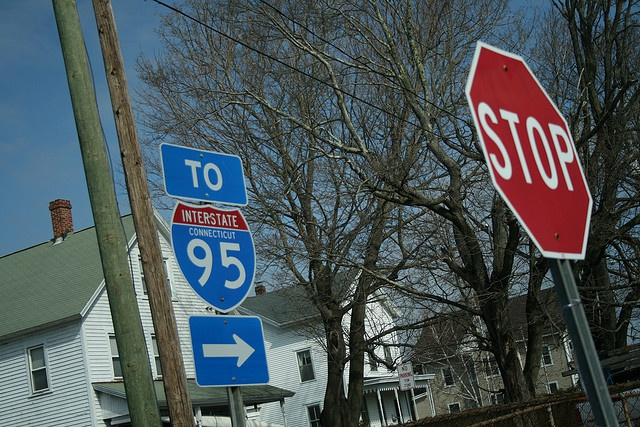Describe the objects in this image and their specific colors. I can see a stop sign in blue, brown, lightblue, lightgray, and darkgray tones in this image. 